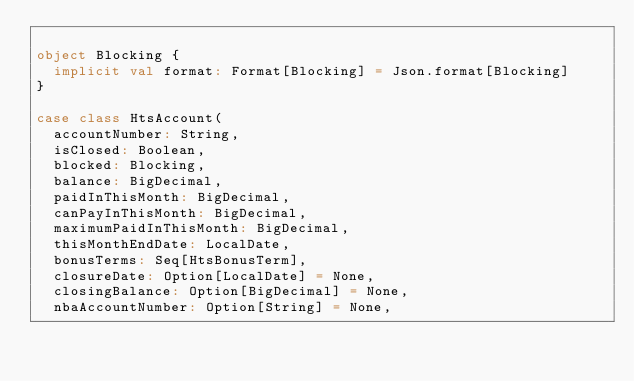<code> <loc_0><loc_0><loc_500><loc_500><_Scala_>
object Blocking {
  implicit val format: Format[Blocking] = Json.format[Blocking]
}

case class HtsAccount(
  accountNumber: String,
  isClosed: Boolean,
  blocked: Blocking,
  balance: BigDecimal,
  paidInThisMonth: BigDecimal,
  canPayInThisMonth: BigDecimal,
  maximumPaidInThisMonth: BigDecimal,
  thisMonthEndDate: LocalDate,
  bonusTerms: Seq[HtsBonusTerm],
  closureDate: Option[LocalDate] = None,
  closingBalance: Option[BigDecimal] = None,
  nbaAccountNumber: Option[String] = None,</code> 